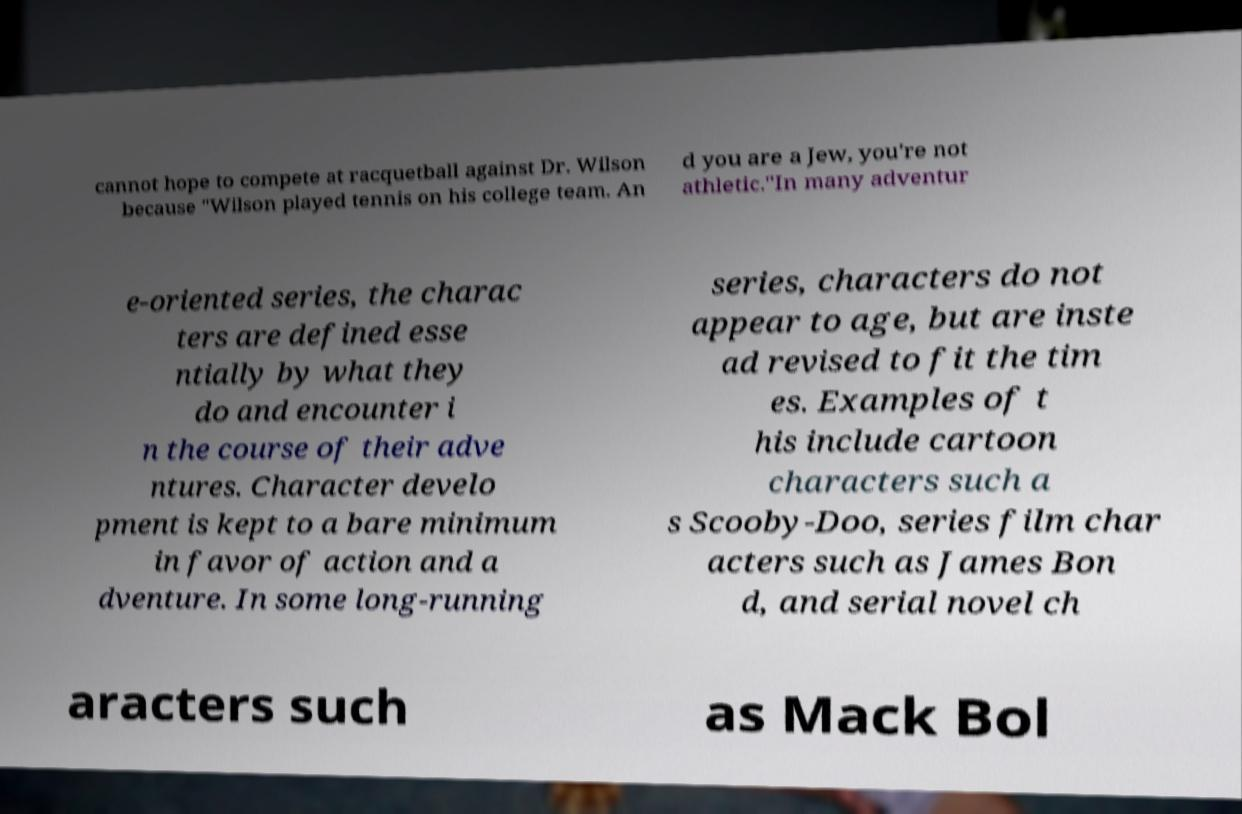I need the written content from this picture converted into text. Can you do that? cannot hope to compete at racquetball against Dr. Wilson because "Wilson played tennis on his college team. An d you are a Jew, you're not athletic."In many adventur e-oriented series, the charac ters are defined esse ntially by what they do and encounter i n the course of their adve ntures. Character develo pment is kept to a bare minimum in favor of action and a dventure. In some long-running series, characters do not appear to age, but are inste ad revised to fit the tim es. Examples of t his include cartoon characters such a s Scooby-Doo, series film char acters such as James Bon d, and serial novel ch aracters such as Mack Bol 